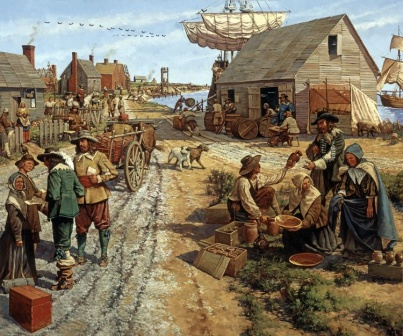Explain the visual content of the image in great detail. The image presents a lively scene from a colonial-era village with a bustling dirt road central to the activity. On the left side, a man balancing a basket filled with fruit on his head walks alongside two women, suggesting a bustling market day. On the right, there is another group consisting of a man and a woman beside a horse-drawn cart loaded with barrels and crates, indicative of trade or transportation activities. Further along, in the distance, a large ship is moored at the harbor, highlighting the village's connection to a body of water, possibly a sea or river, which may have been vital for trade and transportation. The sky is depicted as clear blue, and birds are seen soaring, adding a touch of serenity to the energetic scene below. Various individuals are engaged in different activities, giving a glimpse into the daily life and social structure of the time. The overall composition of the image vividly captures the essence of life in a colonial settlement, showcasing the interplay between people, commerce, and nature. 